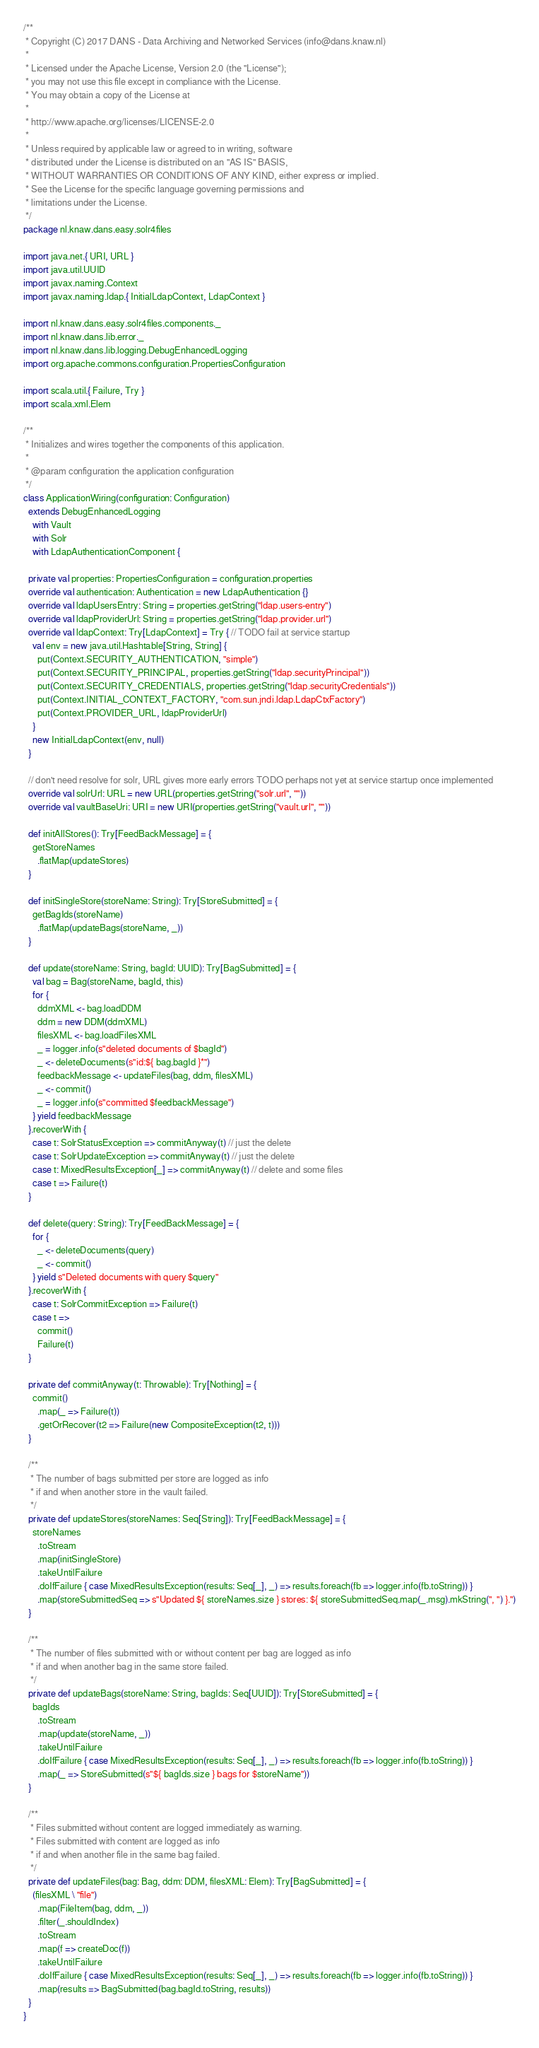<code> <loc_0><loc_0><loc_500><loc_500><_Scala_>/**
 * Copyright (C) 2017 DANS - Data Archiving and Networked Services (info@dans.knaw.nl)
 *
 * Licensed under the Apache License, Version 2.0 (the "License");
 * you may not use this file except in compliance with the License.
 * You may obtain a copy of the License at
 *
 * http://www.apache.org/licenses/LICENSE-2.0
 *
 * Unless required by applicable law or agreed to in writing, software
 * distributed under the License is distributed on an "AS IS" BASIS,
 * WITHOUT WARRANTIES OR CONDITIONS OF ANY KIND, either express or implied.
 * See the License for the specific language governing permissions and
 * limitations under the License.
 */
package nl.knaw.dans.easy.solr4files

import java.net.{ URI, URL }
import java.util.UUID
import javax.naming.Context
import javax.naming.ldap.{ InitialLdapContext, LdapContext }

import nl.knaw.dans.easy.solr4files.components._
import nl.knaw.dans.lib.error._
import nl.knaw.dans.lib.logging.DebugEnhancedLogging
import org.apache.commons.configuration.PropertiesConfiguration

import scala.util.{ Failure, Try }
import scala.xml.Elem

/**
 * Initializes and wires together the components of this application.
 *
 * @param configuration the application configuration
 */
class ApplicationWiring(configuration: Configuration)
  extends DebugEnhancedLogging
    with Vault
    with Solr
    with LdapAuthenticationComponent {

  private val properties: PropertiesConfiguration = configuration.properties
  override val authentication: Authentication = new LdapAuthentication {}
  override val ldapUsersEntry: String = properties.getString("ldap.users-entry")
  override val ldapProviderUrl: String = properties.getString("ldap.provider.url")
  override val ldapContext: Try[LdapContext] = Try { // TODO fail at service startup
    val env = new java.util.Hashtable[String, String] {
      put(Context.SECURITY_AUTHENTICATION, "simple")
      put(Context.SECURITY_PRINCIPAL, properties.getString("ldap.securityPrincipal"))
      put(Context.SECURITY_CREDENTIALS, properties.getString("ldap.securityCredentials"))
      put(Context.INITIAL_CONTEXT_FACTORY, "com.sun.jndi.ldap.LdapCtxFactory")
      put(Context.PROVIDER_URL, ldapProviderUrl)
    }
    new InitialLdapContext(env, null)
  }

  // don't need resolve for solr, URL gives more early errors TODO perhaps not yet at service startup once implemented
  override val solrUrl: URL = new URL(properties.getString("solr.url", ""))
  override val vaultBaseUri: URI = new URI(properties.getString("vault.url", ""))

  def initAllStores(): Try[FeedBackMessage] = {
    getStoreNames
      .flatMap(updateStores)
  }

  def initSingleStore(storeName: String): Try[StoreSubmitted] = {
    getBagIds(storeName)
      .flatMap(updateBags(storeName, _))
  }

  def update(storeName: String, bagId: UUID): Try[BagSubmitted] = {
    val bag = Bag(storeName, bagId, this)
    for {
      ddmXML <- bag.loadDDM
      ddm = new DDM(ddmXML)
      filesXML <- bag.loadFilesXML
      _ = logger.info(s"deleted documents of $bagId")
      _ <- deleteDocuments(s"id:${ bag.bagId }*")
      feedbackMessage <- updateFiles(bag, ddm, filesXML)
      _ <- commit()
      _ = logger.info(s"committed $feedbackMessage")
    } yield feedbackMessage
  }.recoverWith {
    case t: SolrStatusException => commitAnyway(t) // just the delete
    case t: SolrUpdateException => commitAnyway(t) // just the delete
    case t: MixedResultsException[_] => commitAnyway(t) // delete and some files
    case t => Failure(t)
  }

  def delete(query: String): Try[FeedBackMessage] = {
    for {
      _ <- deleteDocuments(query)
      _ <- commit()
    } yield s"Deleted documents with query $query"
  }.recoverWith {
    case t: SolrCommitException => Failure(t)
    case t =>
      commit()
      Failure(t)
  }

  private def commitAnyway(t: Throwable): Try[Nothing] = {
    commit()
      .map(_ => Failure(t))
      .getOrRecover(t2 => Failure(new CompositeException(t2, t)))
  }

  /**
   * The number of bags submitted per store are logged as info
   * if and when another store in the vault failed.
   */
  private def updateStores(storeNames: Seq[String]): Try[FeedBackMessage] = {
    storeNames
      .toStream
      .map(initSingleStore)
      .takeUntilFailure
      .doIfFailure { case MixedResultsException(results: Seq[_], _) => results.foreach(fb => logger.info(fb.toString)) }
      .map(storeSubmittedSeq => s"Updated ${ storeNames.size } stores: ${ storeSubmittedSeq.map(_.msg).mkString(", ") }.")
  }

  /**
   * The number of files submitted with or without content per bag are logged as info
   * if and when another bag in the same store failed.
   */
  private def updateBags(storeName: String, bagIds: Seq[UUID]): Try[StoreSubmitted] = {
    bagIds
      .toStream
      .map(update(storeName, _))
      .takeUntilFailure
      .doIfFailure { case MixedResultsException(results: Seq[_], _) => results.foreach(fb => logger.info(fb.toString)) }
      .map(_ => StoreSubmitted(s"${ bagIds.size } bags for $storeName"))
  }

  /**
   * Files submitted without content are logged immediately as warning.
   * Files submitted with content are logged as info
   * if and when another file in the same bag failed.
   */
  private def updateFiles(bag: Bag, ddm: DDM, filesXML: Elem): Try[BagSubmitted] = {
    (filesXML \ "file")
      .map(FileItem(bag, ddm, _))
      .filter(_.shouldIndex)
      .toStream
      .map(f => createDoc(f))
      .takeUntilFailure
      .doIfFailure { case MixedResultsException(results: Seq[_], _) => results.foreach(fb => logger.info(fb.toString)) }
      .map(results => BagSubmitted(bag.bagId.toString, results))
  }
}
</code> 